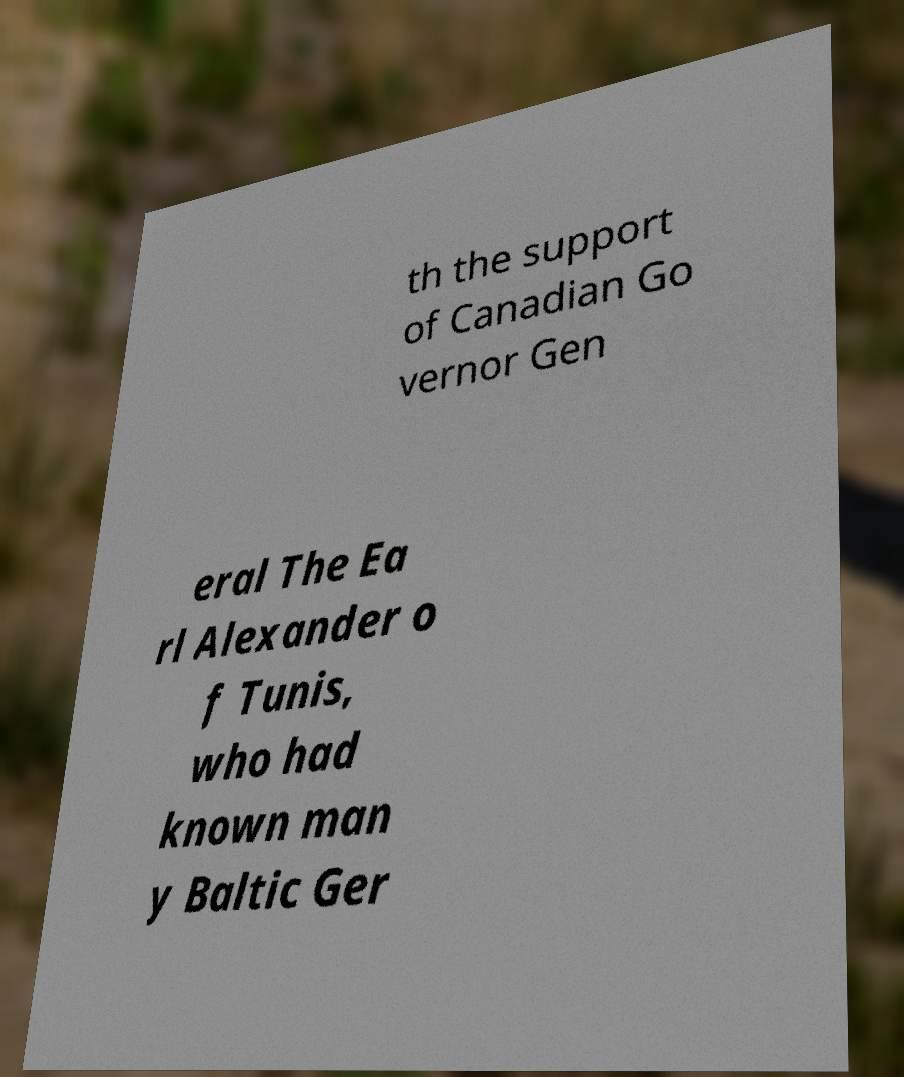Can you accurately transcribe the text from the provided image for me? th the support of Canadian Go vernor Gen eral The Ea rl Alexander o f Tunis, who had known man y Baltic Ger 